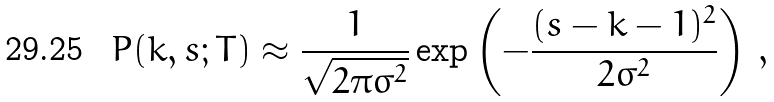<formula> <loc_0><loc_0><loc_500><loc_500>P ( k , s ; T ) \approx \frac { 1 } { \sqrt { 2 \pi \sigma ^ { 2 } } } \exp \left ( - \frac { ( s - k - 1 ) ^ { 2 } } { 2 \sigma ^ { 2 } } \right ) \, ,</formula> 